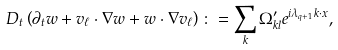Convert formula to latex. <formula><loc_0><loc_0><loc_500><loc_500>D _ { t } \left ( \partial _ { t } w + v _ { \ell } \cdot \nabla w + w \cdot \nabla v _ { \ell } \right ) \colon = \sum _ { k } \Omega ^ { \prime } _ { k l } e ^ { i \lambda _ { q + 1 } k \cdot x } ,</formula> 